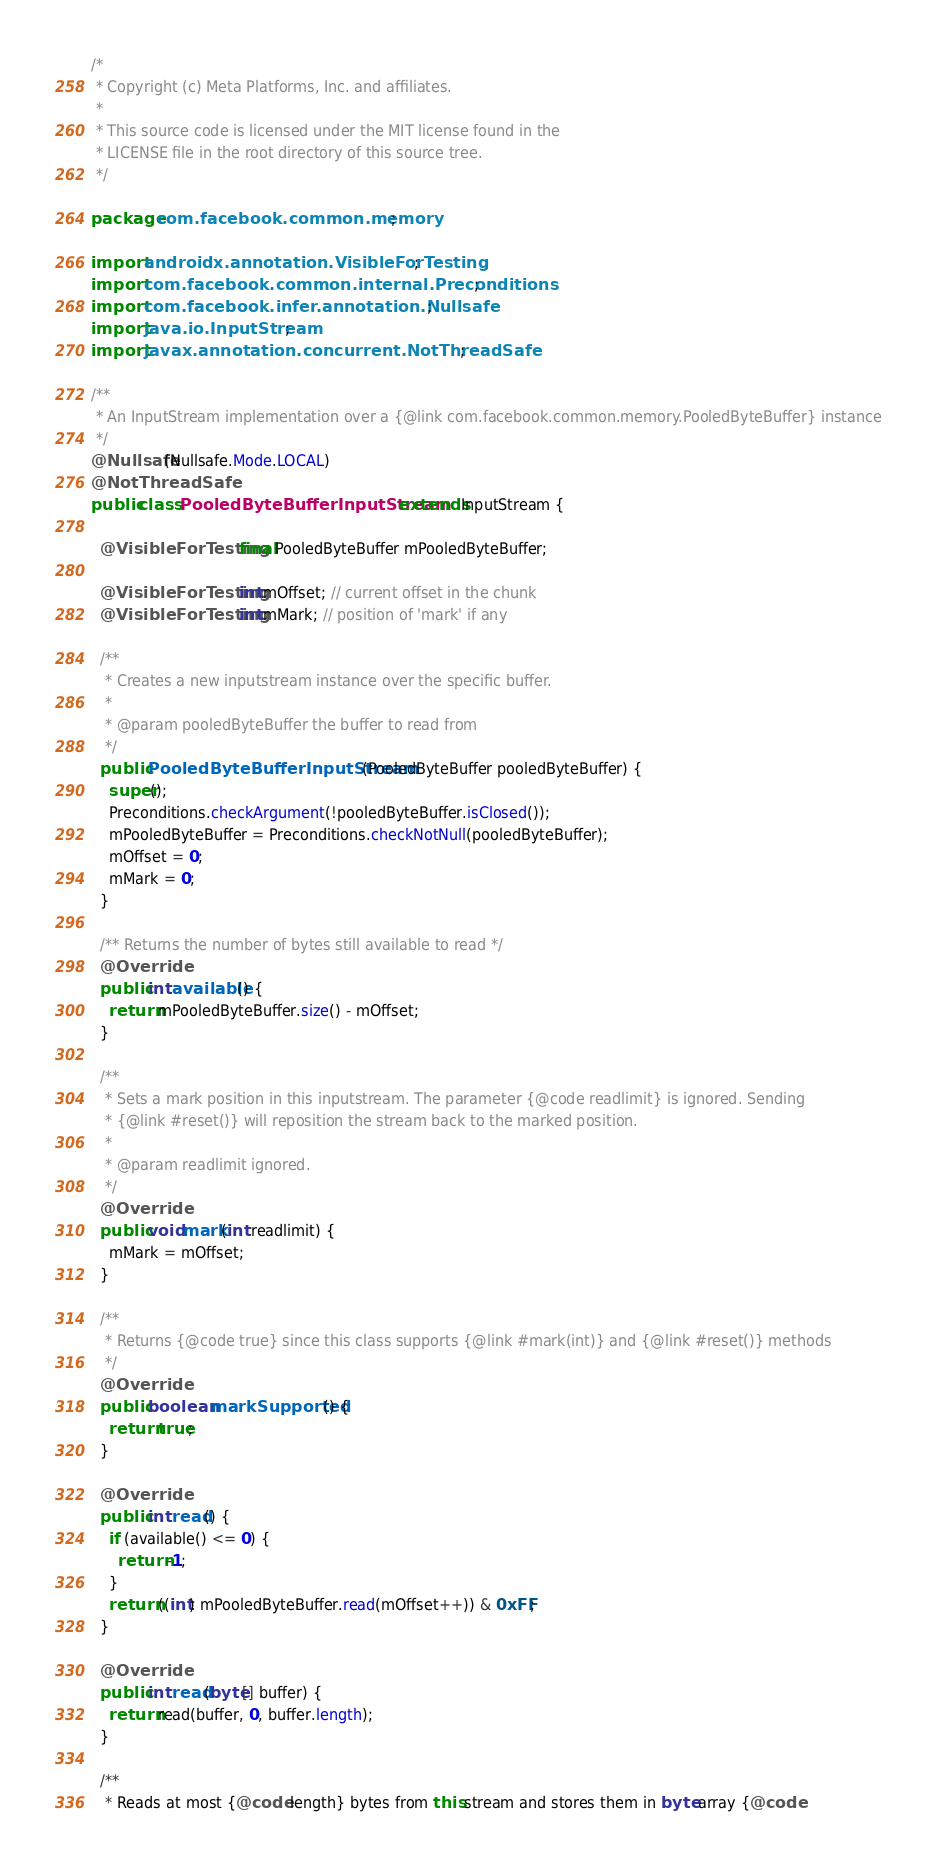<code> <loc_0><loc_0><loc_500><loc_500><_Java_>/*
 * Copyright (c) Meta Platforms, Inc. and affiliates.
 *
 * This source code is licensed under the MIT license found in the
 * LICENSE file in the root directory of this source tree.
 */

package com.facebook.common.memory;

import androidx.annotation.VisibleForTesting;
import com.facebook.common.internal.Preconditions;
import com.facebook.infer.annotation.Nullsafe;
import java.io.InputStream;
import javax.annotation.concurrent.NotThreadSafe;

/**
 * An InputStream implementation over a {@link com.facebook.common.memory.PooledByteBuffer} instance
 */
@Nullsafe(Nullsafe.Mode.LOCAL)
@NotThreadSafe
public class PooledByteBufferInputStream extends InputStream {

  @VisibleForTesting final PooledByteBuffer mPooledByteBuffer;

  @VisibleForTesting int mOffset; // current offset in the chunk
  @VisibleForTesting int mMark; // position of 'mark' if any

  /**
   * Creates a new inputstream instance over the specific buffer.
   *
   * @param pooledByteBuffer the buffer to read from
   */
  public PooledByteBufferInputStream(PooledByteBuffer pooledByteBuffer) {
    super();
    Preconditions.checkArgument(!pooledByteBuffer.isClosed());
    mPooledByteBuffer = Preconditions.checkNotNull(pooledByteBuffer);
    mOffset = 0;
    mMark = 0;
  }

  /** Returns the number of bytes still available to read */
  @Override
  public int available() {
    return mPooledByteBuffer.size() - mOffset;
  }

  /**
   * Sets a mark position in this inputstream. The parameter {@code readlimit} is ignored. Sending
   * {@link #reset()} will reposition the stream back to the marked position.
   *
   * @param readlimit ignored.
   */
  @Override
  public void mark(int readlimit) {
    mMark = mOffset;
  }

  /**
   * Returns {@code true} since this class supports {@link #mark(int)} and {@link #reset()} methods
   */
  @Override
  public boolean markSupported() {
    return true;
  }

  @Override
  public int read() {
    if (available() <= 0) {
      return -1;
    }
    return ((int) mPooledByteBuffer.read(mOffset++)) & 0xFF;
  }

  @Override
  public int read(byte[] buffer) {
    return read(buffer, 0, buffer.length);
  }

  /**
   * Reads at most {@code length} bytes from this stream and stores them in byte array {@code</code> 